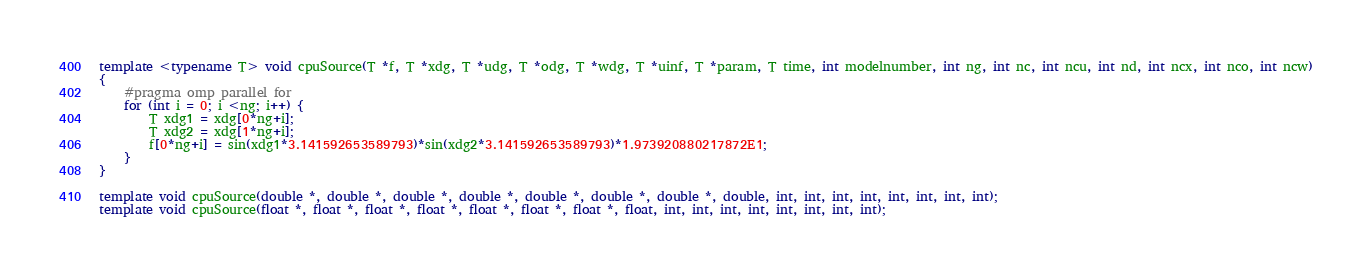<code> <loc_0><loc_0><loc_500><loc_500><_C++_>template <typename T> void cpuSource(T *f, T *xdg, T *udg, T *odg, T *wdg, T *uinf, T *param, T time, int modelnumber, int ng, int nc, int ncu, int nd, int ncx, int nco, int ncw)
{
	#pragma omp parallel for
	for (int i = 0; i <ng; i++) {
		T xdg1 = xdg[0*ng+i];
		T xdg2 = xdg[1*ng+i];
		f[0*ng+i] = sin(xdg1*3.141592653589793)*sin(xdg2*3.141592653589793)*1.973920880217872E1;
	}
}

template void cpuSource(double *, double *, double *, double *, double *, double *, double *, double, int, int, int, int, int, int, int, int);
template void cpuSource(float *, float *, float *, float *, float *, float *, float *, float, int, int, int, int, int, int, int, int);
</code> 